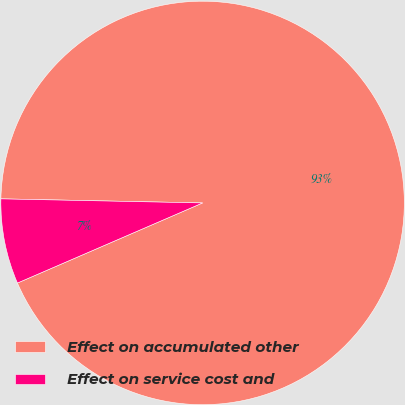Convert chart. <chart><loc_0><loc_0><loc_500><loc_500><pie_chart><fcel>Effect on accumulated other<fcel>Effect on service cost and<nl><fcel>93.18%<fcel>6.82%<nl></chart> 